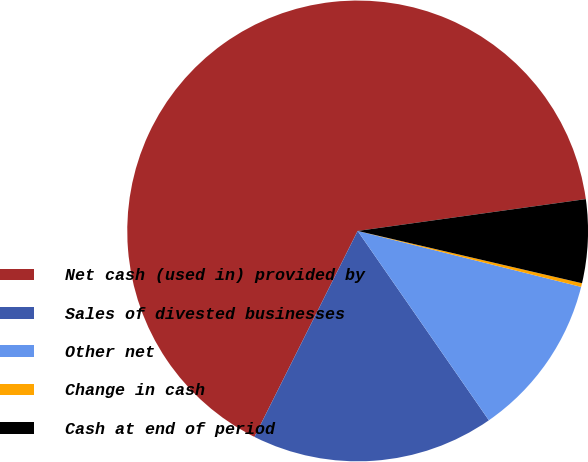Convert chart to OTSL. <chart><loc_0><loc_0><loc_500><loc_500><pie_chart><fcel>Net cash (used in) provided by<fcel>Sales of divested businesses<fcel>Other net<fcel>Change in cash<fcel>Cash at end of period<nl><fcel>65.4%<fcel>17.04%<fcel>11.45%<fcel>0.26%<fcel>5.85%<nl></chart> 